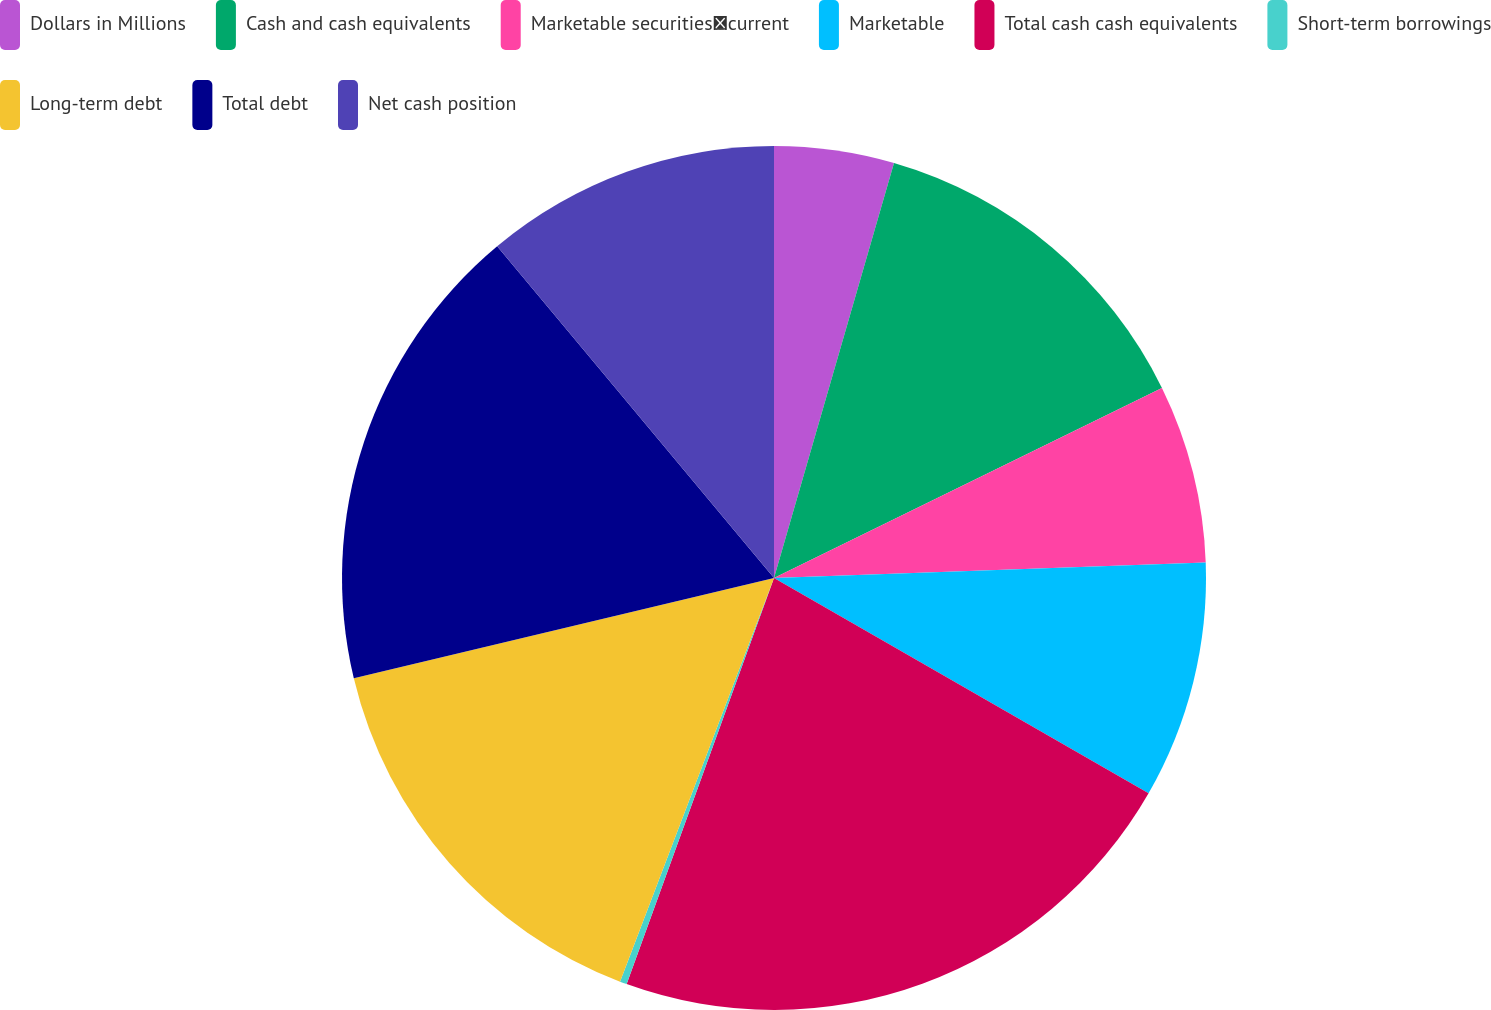Convert chart. <chart><loc_0><loc_0><loc_500><loc_500><pie_chart><fcel>Dollars in Millions<fcel>Cash and cash equivalents<fcel>Marketable securitiescurrent<fcel>Marketable<fcel>Total cash cash equivalents<fcel>Short-term borrowings<fcel>Long-term debt<fcel>Total debt<fcel>Net cash position<nl><fcel>4.48%<fcel>13.27%<fcel>6.68%<fcel>8.87%<fcel>22.24%<fcel>0.26%<fcel>15.47%<fcel>17.66%<fcel>11.07%<nl></chart> 